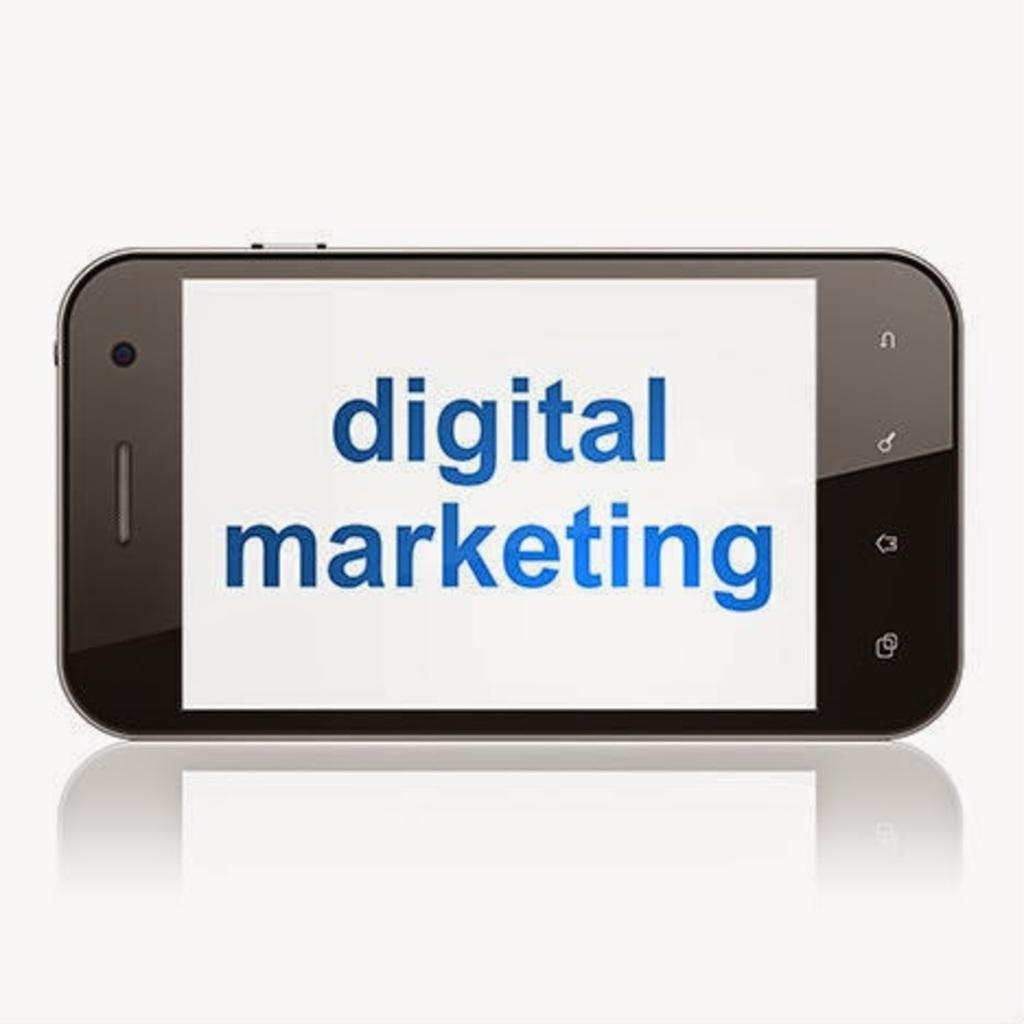<image>
Describe the image concisely. An image of a smart phone displaying the message digital marketing. 